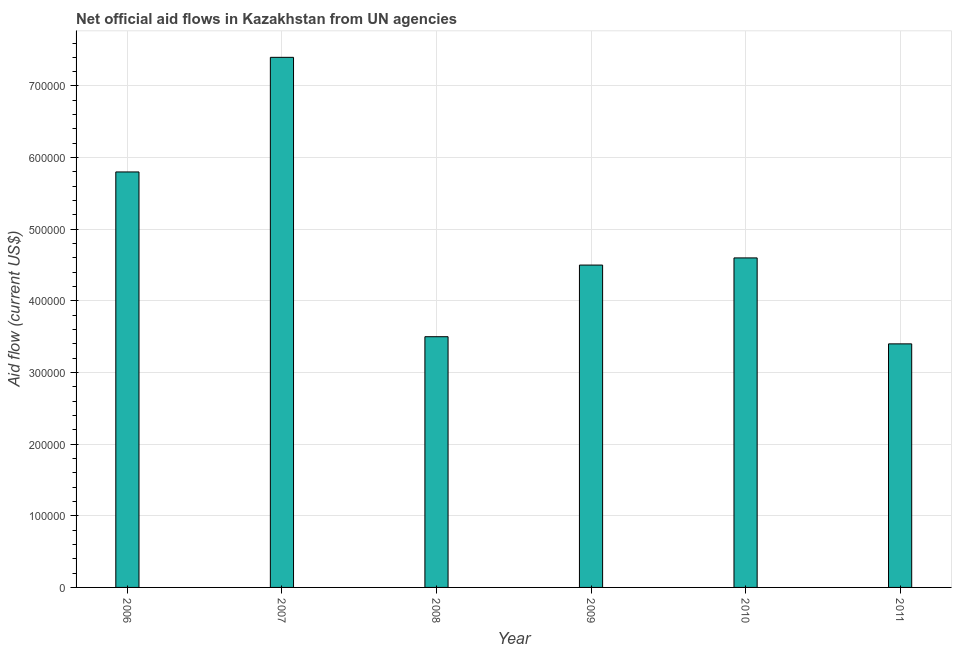Does the graph contain any zero values?
Make the answer very short. No. What is the title of the graph?
Your answer should be compact. Net official aid flows in Kazakhstan from UN agencies. What is the label or title of the X-axis?
Provide a succinct answer. Year. What is the label or title of the Y-axis?
Your answer should be compact. Aid flow (current US$). Across all years, what is the maximum net official flows from un agencies?
Your response must be concise. 7.40e+05. Across all years, what is the minimum net official flows from un agencies?
Your answer should be very brief. 3.40e+05. What is the sum of the net official flows from un agencies?
Make the answer very short. 2.92e+06. What is the average net official flows from un agencies per year?
Keep it short and to the point. 4.87e+05. What is the median net official flows from un agencies?
Your answer should be compact. 4.55e+05. In how many years, is the net official flows from un agencies greater than 300000 US$?
Provide a short and direct response. 6. Do a majority of the years between 2010 and 2007 (inclusive) have net official flows from un agencies greater than 680000 US$?
Provide a short and direct response. Yes. Is the net official flows from un agencies in 2009 less than that in 2010?
Provide a short and direct response. Yes. Is the difference between the net official flows from un agencies in 2006 and 2010 greater than the difference between any two years?
Ensure brevity in your answer.  No. Are all the bars in the graph horizontal?
Your answer should be very brief. No. How many years are there in the graph?
Your response must be concise. 6. What is the Aid flow (current US$) in 2006?
Make the answer very short. 5.80e+05. What is the Aid flow (current US$) in 2007?
Offer a very short reply. 7.40e+05. What is the Aid flow (current US$) in 2008?
Offer a very short reply. 3.50e+05. What is the Aid flow (current US$) of 2009?
Your answer should be very brief. 4.50e+05. What is the difference between the Aid flow (current US$) in 2006 and 2008?
Ensure brevity in your answer.  2.30e+05. What is the difference between the Aid flow (current US$) in 2006 and 2010?
Ensure brevity in your answer.  1.20e+05. What is the difference between the Aid flow (current US$) in 2007 and 2008?
Make the answer very short. 3.90e+05. What is the difference between the Aid flow (current US$) in 2007 and 2010?
Ensure brevity in your answer.  2.80e+05. What is the difference between the Aid flow (current US$) in 2007 and 2011?
Give a very brief answer. 4.00e+05. What is the difference between the Aid flow (current US$) in 2009 and 2011?
Your answer should be very brief. 1.10e+05. What is the ratio of the Aid flow (current US$) in 2006 to that in 2007?
Offer a terse response. 0.78. What is the ratio of the Aid flow (current US$) in 2006 to that in 2008?
Offer a terse response. 1.66. What is the ratio of the Aid flow (current US$) in 2006 to that in 2009?
Give a very brief answer. 1.29. What is the ratio of the Aid flow (current US$) in 2006 to that in 2010?
Offer a very short reply. 1.26. What is the ratio of the Aid flow (current US$) in 2006 to that in 2011?
Offer a very short reply. 1.71. What is the ratio of the Aid flow (current US$) in 2007 to that in 2008?
Your answer should be very brief. 2.11. What is the ratio of the Aid flow (current US$) in 2007 to that in 2009?
Keep it short and to the point. 1.64. What is the ratio of the Aid flow (current US$) in 2007 to that in 2010?
Your answer should be very brief. 1.61. What is the ratio of the Aid flow (current US$) in 2007 to that in 2011?
Your answer should be compact. 2.18. What is the ratio of the Aid flow (current US$) in 2008 to that in 2009?
Give a very brief answer. 0.78. What is the ratio of the Aid flow (current US$) in 2008 to that in 2010?
Give a very brief answer. 0.76. What is the ratio of the Aid flow (current US$) in 2008 to that in 2011?
Ensure brevity in your answer.  1.03. What is the ratio of the Aid flow (current US$) in 2009 to that in 2010?
Offer a very short reply. 0.98. What is the ratio of the Aid flow (current US$) in 2009 to that in 2011?
Your answer should be very brief. 1.32. What is the ratio of the Aid flow (current US$) in 2010 to that in 2011?
Offer a terse response. 1.35. 